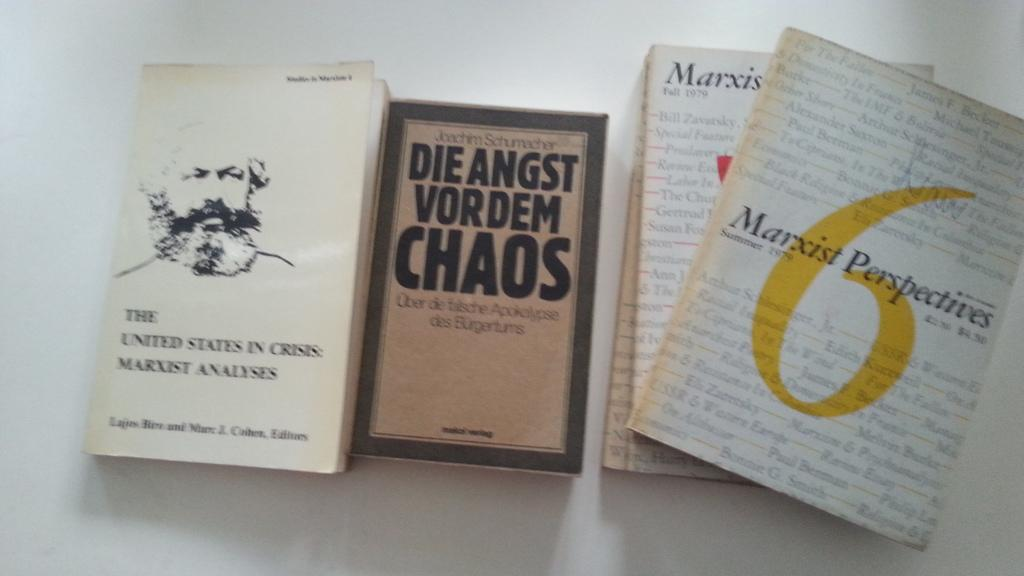<image>
Create a compact narrative representing the image presented. Some books are on a table including one titled Marxist Perspectives. 